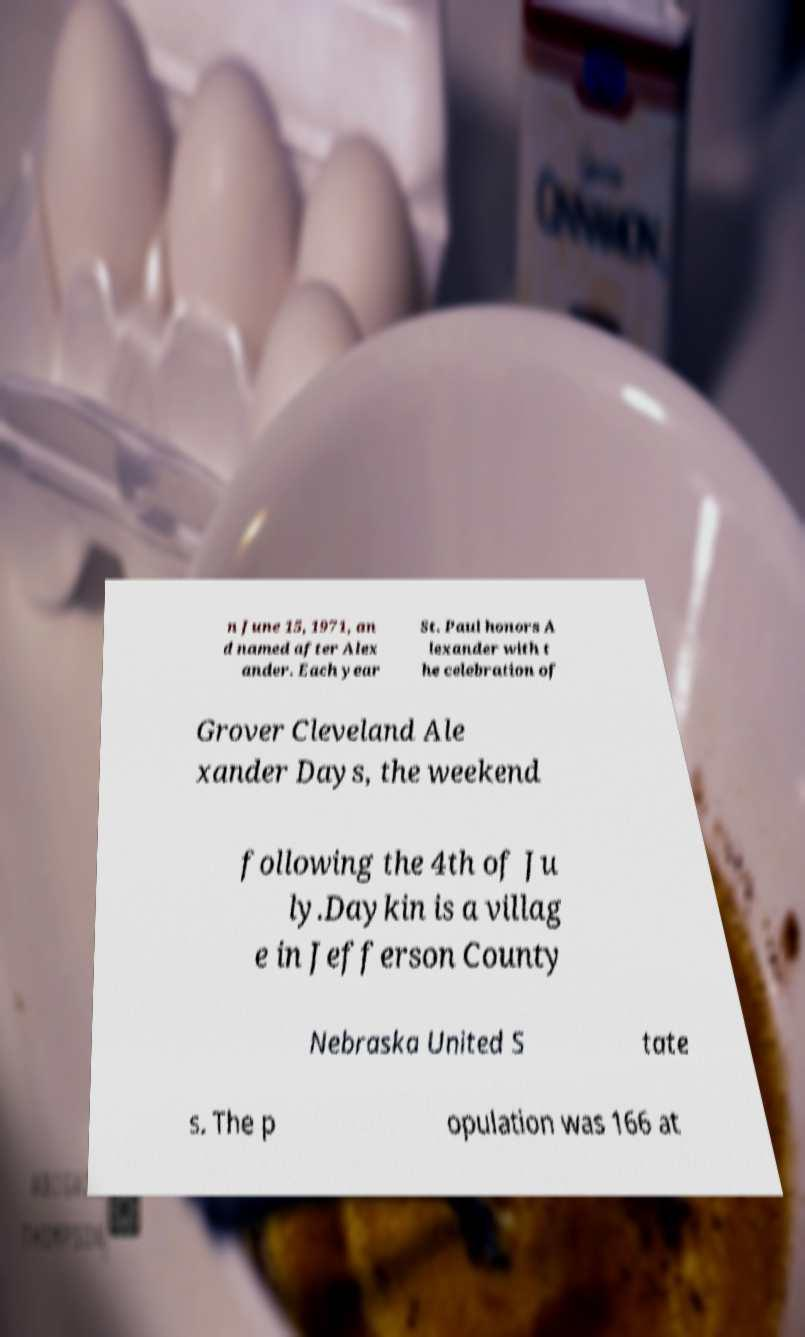What messages or text are displayed in this image? I need them in a readable, typed format. n June 15, 1971, an d named after Alex ander. Each year St. Paul honors A lexander with t he celebration of Grover Cleveland Ale xander Days, the weekend following the 4th of Ju ly.Daykin is a villag e in Jefferson County Nebraska United S tate s. The p opulation was 166 at 